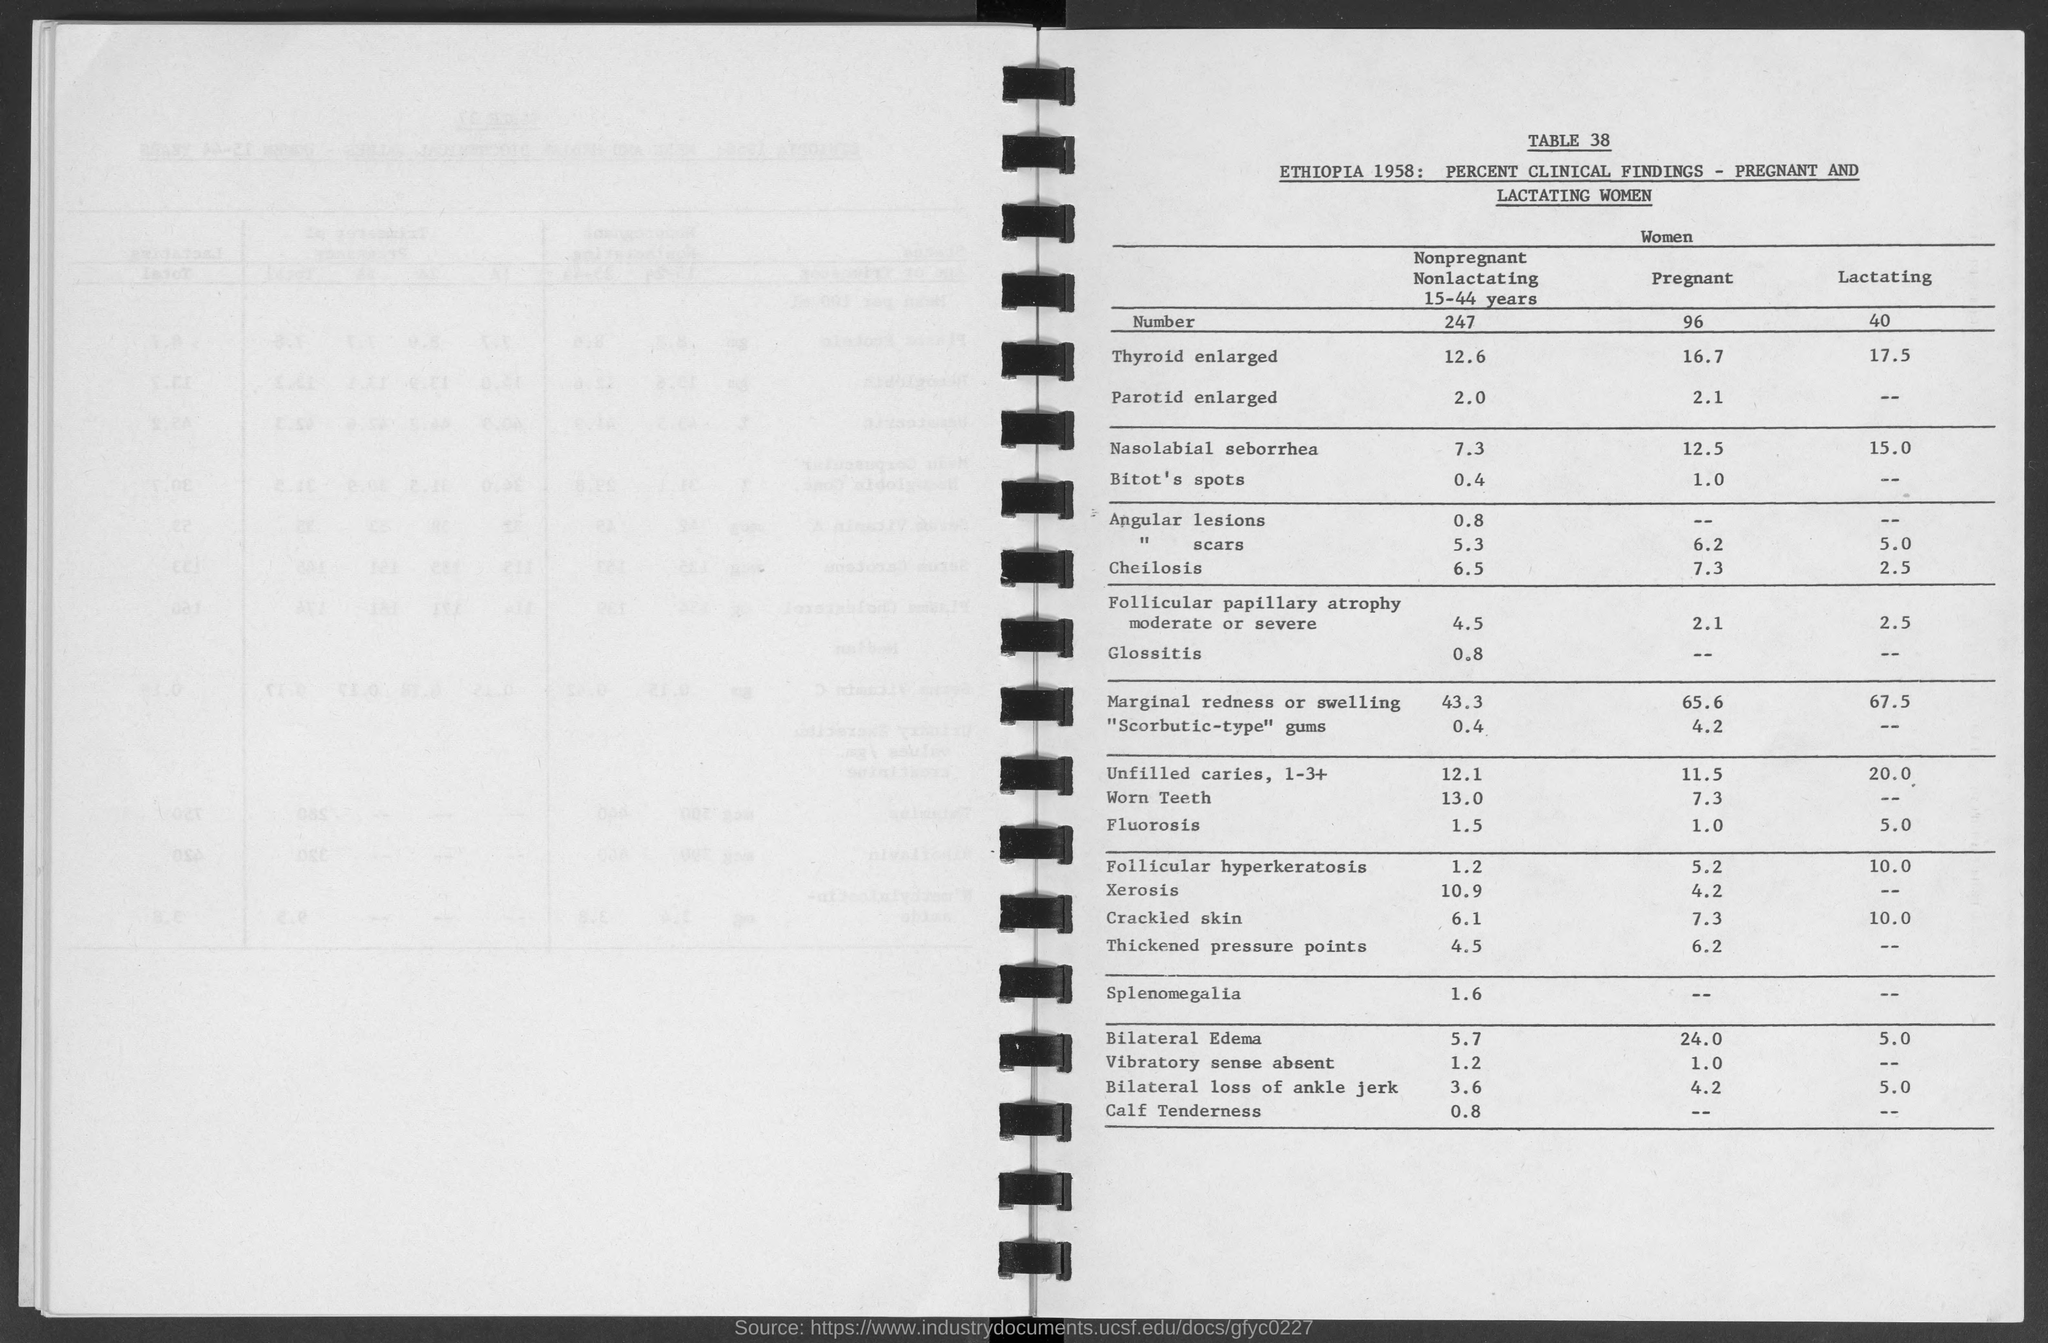Draw attention to some important aspects in this diagram. Can you please provide the table number for 38? 